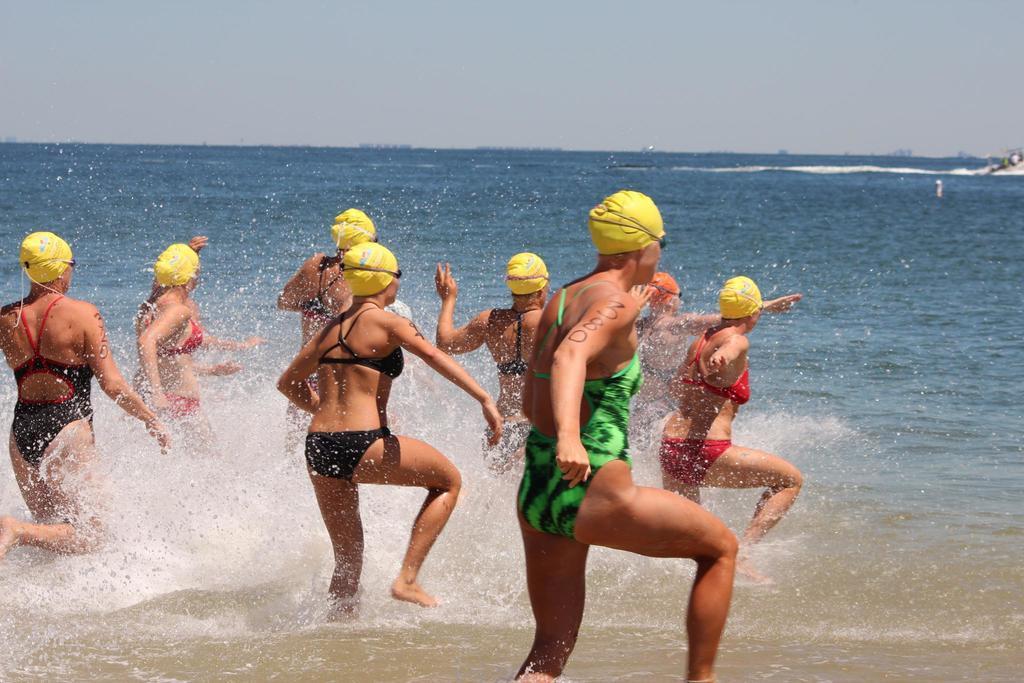In one or two sentences, can you explain what this image depicts? This picture shows human getting into the water and they wore caps on their heads and we see a cloudy Sky. 